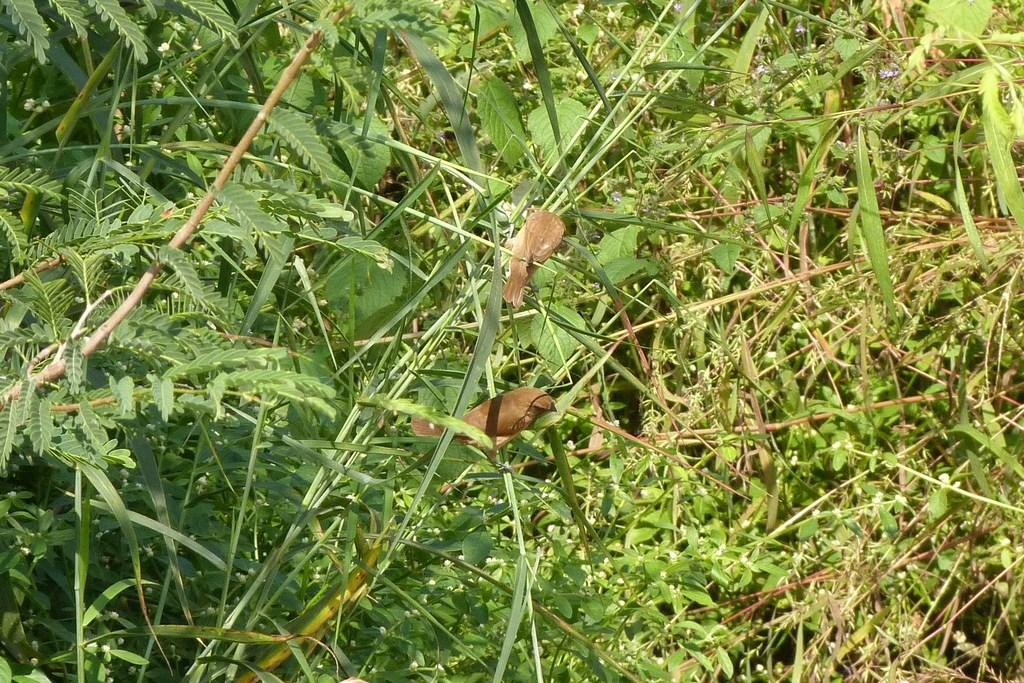How many birds can be seen in the image? There are two small birds in the image. What are the birds standing on? The birds are standing on the branches of plants. What type of vegetation is present in the image? There are many small plants and grass visible in the image. Can you see a record player in the image? There is no record player present in the image. Is there a squirrel eating lunch in the image? There is no squirrel or lunch depicted in the image; it features two small birds standing on the branches of plants. 